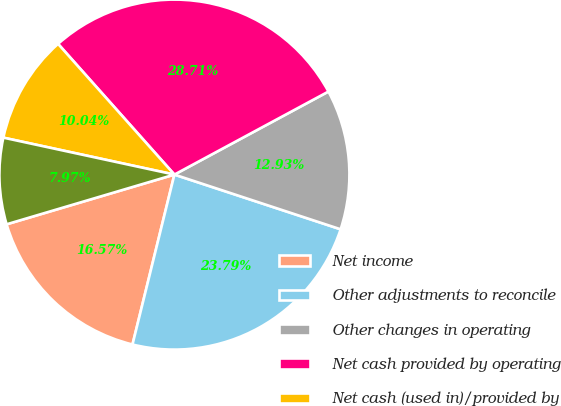Convert chart. <chart><loc_0><loc_0><loc_500><loc_500><pie_chart><fcel>Net income<fcel>Other adjustments to reconcile<fcel>Other changes in operating<fcel>Net cash provided by operating<fcel>Net cash (used in)/provided by<fcel>Net cash used in financing<nl><fcel>16.57%<fcel>23.79%<fcel>12.93%<fcel>28.71%<fcel>10.04%<fcel>7.97%<nl></chart> 